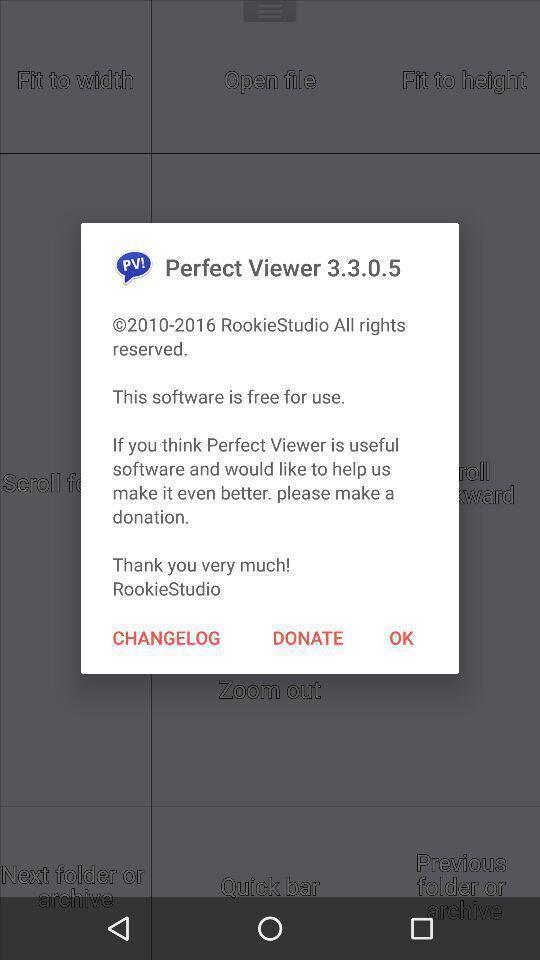Give me a summary of this screen capture. Pop-up to make a donation options for software app. 